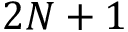Convert formula to latex. <formula><loc_0><loc_0><loc_500><loc_500>2 N + 1</formula> 